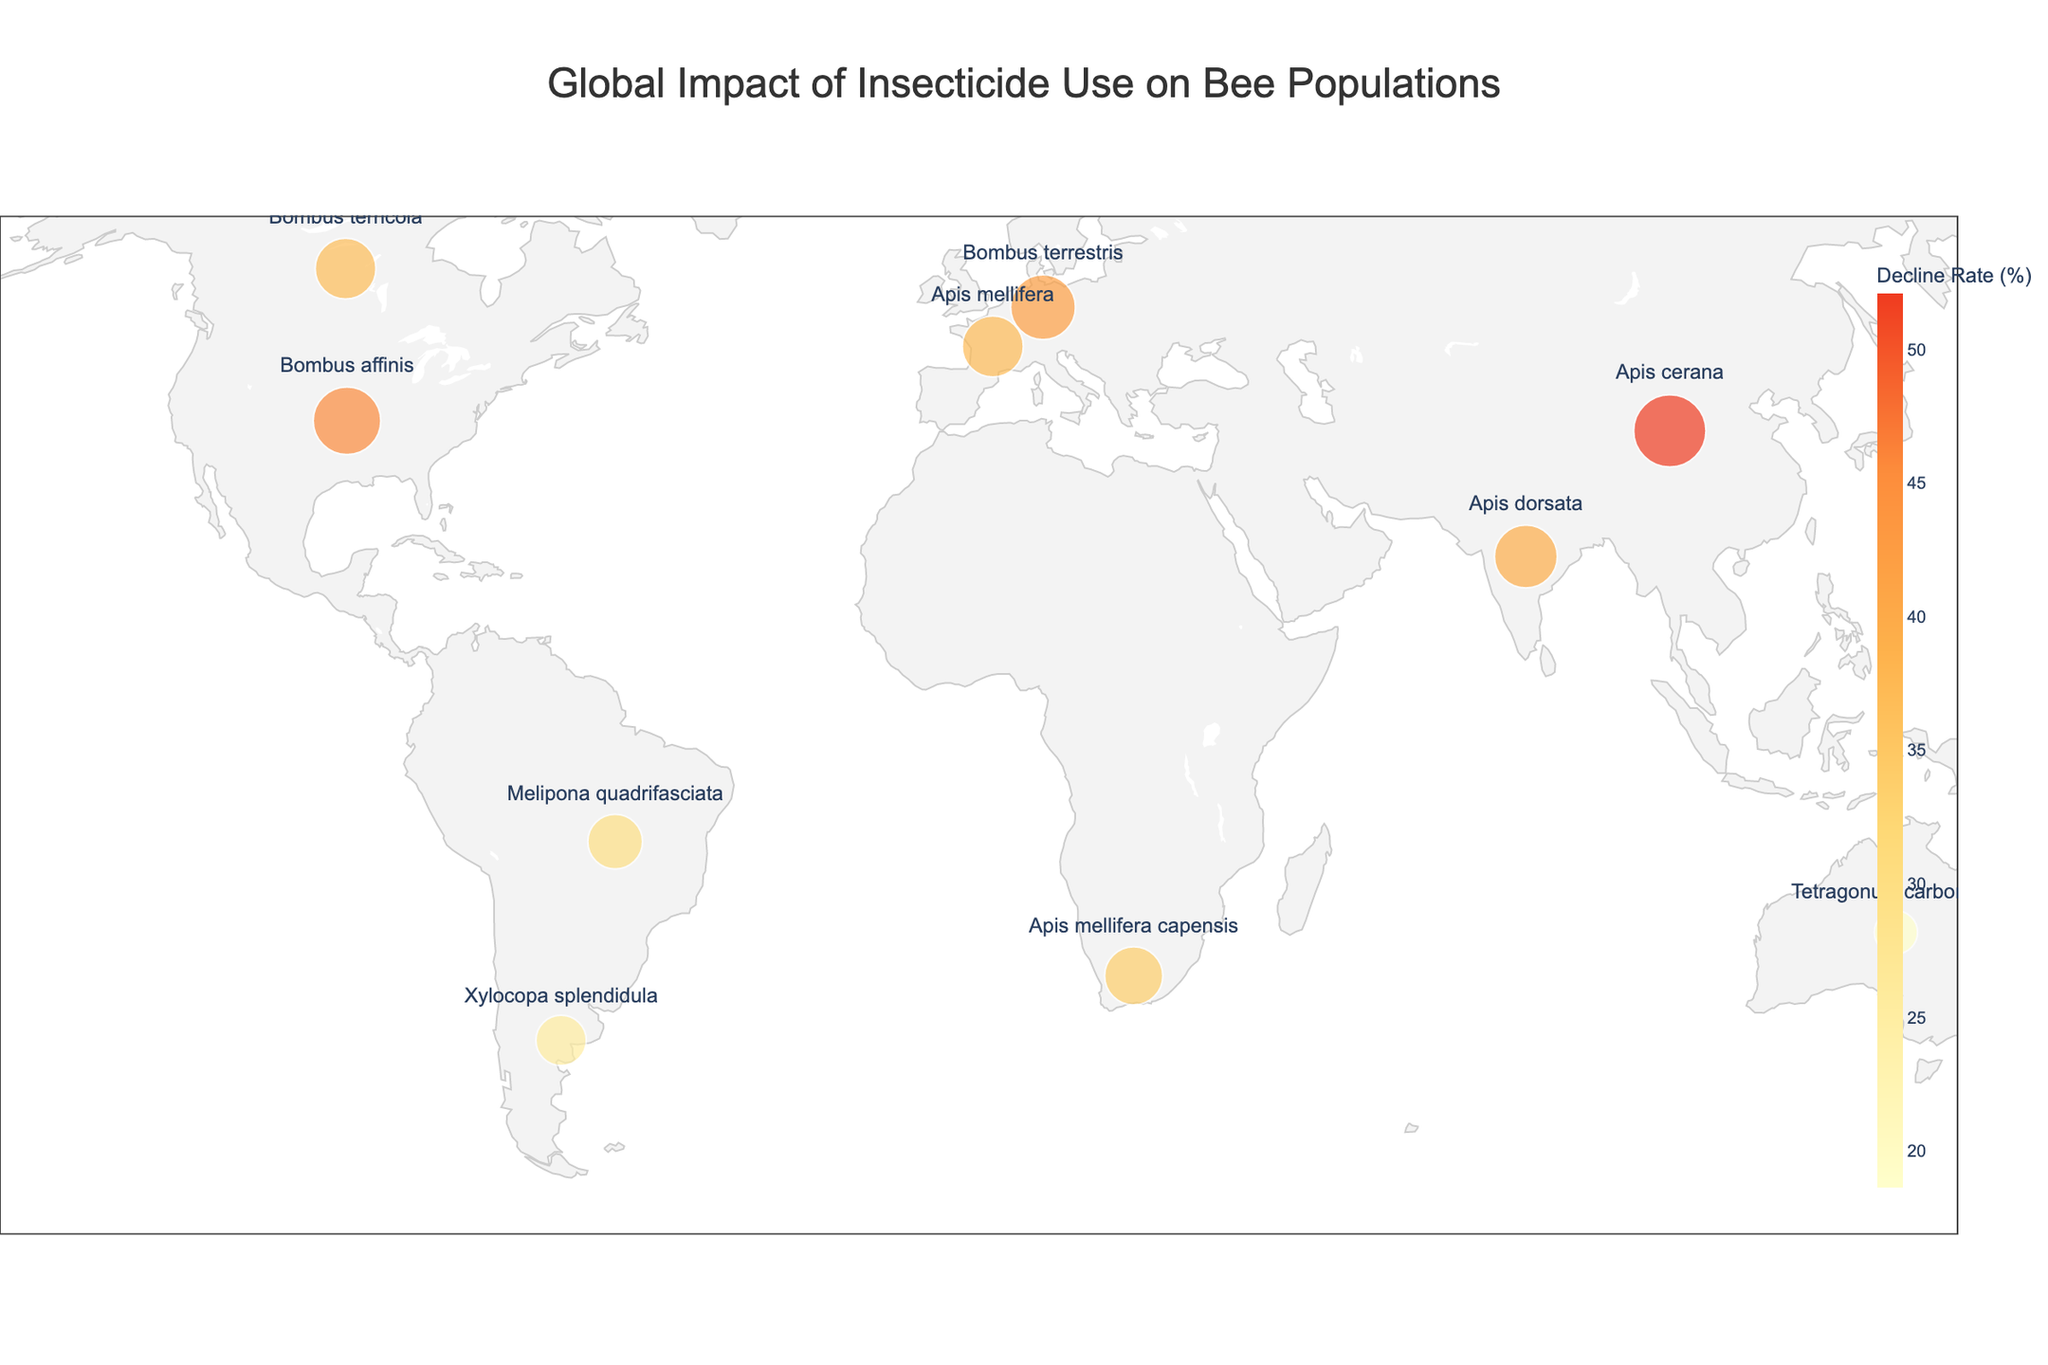How many countries are visualized on the map? Count the number of countries listed on the map, each represented by a unique data point. There are 10 countries displayed.
Answer: 10 Which country has the highest bee population decline rate? Look for the data point with the highest value for "Bee Population Decline Rate (%)". China has the highest decline rate of 52.1%.
Answer: China Among the countries listed, which one has the lowest bee population decline rate? Identify the data point with the lowest value for "Bee Population Decline Rate (%)". Australia has the lowest decline rate of 18.6%.
Answer: Australia What is the primary insecticide used in Canada? Find the data point representing Canada and check the label for "Primary Insecticide Used". Canada uses Neonicotinoids.
Answer: Neonicotinoids Compare the bee population decline rates between the United States and Germany. Which country has a higher decline rate? Look at the values for "Bee Population Decline Rate (%)" for both countries. The United States has a decline rate of 45.5%, while Germany has 41.9%. Thus, the United States has a higher decline rate.
Answer: United States Which bee species is most affected in France? Locate France on the map and reference the label for "Most Affected Bee Species". The most affected bee species in France is Apis mellifera.
Answer: Apis mellifera What is the average bee population decline rate across all the countries? Summate the decline rates for all countries and then divide by the number of countries: (45.5 + 37.2 + 29.8 + 52.1 + 18.6 + 33.7 + 41.9 + 39.4 + 25.3 + 36.8) / 10 = 36.03.
Answer: 36.03 Which countries use Neonicotinoids as their primary insecticide? Identify the countries listed with Neonicotinoids as their "Primary Insecticide Used". The United States, Germany, and Canada use Neonicotinoids.
Answer: United States, Germany, Canada What is the decline rate difference between Brazil and Argentina? Subtract the decline rate for Argentina from Brazil's: 29.8% - 25.3% = 4.5%.
Answer: 4.5% Is the decline rate in India greater than the average decline rate? Compare India's decline rate of 39.4% to the average decline rate of 36.03%. Yes, India's decline rate is greater.
Answer: Yes 